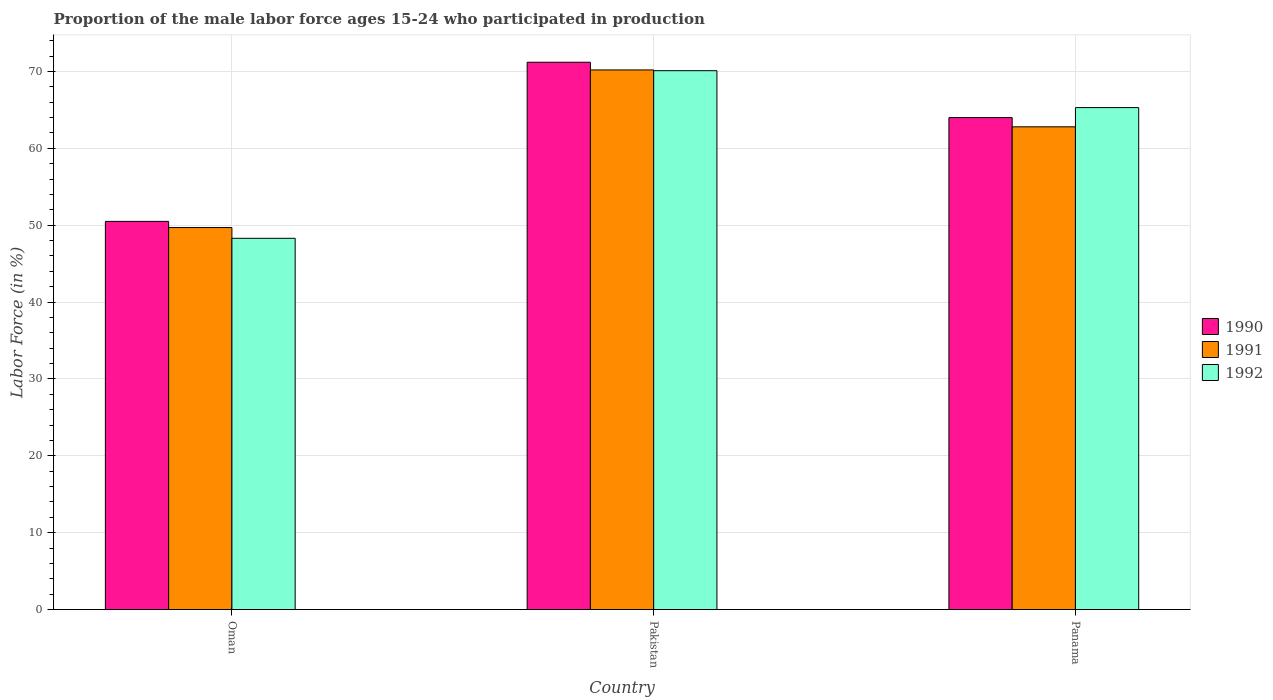How many different coloured bars are there?
Provide a short and direct response. 3. How many groups of bars are there?
Offer a terse response. 3. How many bars are there on the 3rd tick from the left?
Your response must be concise. 3. What is the label of the 3rd group of bars from the left?
Give a very brief answer. Panama. In how many cases, is the number of bars for a given country not equal to the number of legend labels?
Your answer should be very brief. 0. What is the proportion of the male labor force who participated in production in 1990 in Pakistan?
Your response must be concise. 71.2. Across all countries, what is the maximum proportion of the male labor force who participated in production in 1992?
Your response must be concise. 70.1. Across all countries, what is the minimum proportion of the male labor force who participated in production in 1991?
Make the answer very short. 49.7. In which country was the proportion of the male labor force who participated in production in 1992 maximum?
Your answer should be very brief. Pakistan. In which country was the proportion of the male labor force who participated in production in 1991 minimum?
Offer a terse response. Oman. What is the total proportion of the male labor force who participated in production in 1991 in the graph?
Make the answer very short. 182.7. What is the difference between the proportion of the male labor force who participated in production in 1990 in Oman and that in Panama?
Make the answer very short. -13.5. What is the difference between the proportion of the male labor force who participated in production in 1992 in Pakistan and the proportion of the male labor force who participated in production in 1990 in Panama?
Your answer should be compact. 6.1. What is the average proportion of the male labor force who participated in production in 1992 per country?
Your answer should be compact. 61.23. What is the difference between the proportion of the male labor force who participated in production of/in 1991 and proportion of the male labor force who participated in production of/in 1992 in Oman?
Provide a short and direct response. 1.4. What is the ratio of the proportion of the male labor force who participated in production in 1992 in Oman to that in Panama?
Your response must be concise. 0.74. What is the difference between the highest and the second highest proportion of the male labor force who participated in production in 1991?
Offer a terse response. 13.1. What is the difference between the highest and the lowest proportion of the male labor force who participated in production in 1991?
Your answer should be compact. 20.5. In how many countries, is the proportion of the male labor force who participated in production in 1990 greater than the average proportion of the male labor force who participated in production in 1990 taken over all countries?
Give a very brief answer. 2. What does the 3rd bar from the left in Oman represents?
Offer a terse response. 1992. Is it the case that in every country, the sum of the proportion of the male labor force who participated in production in 1992 and proportion of the male labor force who participated in production in 1991 is greater than the proportion of the male labor force who participated in production in 1990?
Keep it short and to the point. Yes. How many bars are there?
Give a very brief answer. 9. Are all the bars in the graph horizontal?
Your answer should be compact. No. Are the values on the major ticks of Y-axis written in scientific E-notation?
Provide a succinct answer. No. Does the graph contain grids?
Make the answer very short. Yes. Where does the legend appear in the graph?
Your response must be concise. Center right. How many legend labels are there?
Your response must be concise. 3. How are the legend labels stacked?
Offer a very short reply. Vertical. What is the title of the graph?
Your response must be concise. Proportion of the male labor force ages 15-24 who participated in production. What is the label or title of the X-axis?
Give a very brief answer. Country. What is the label or title of the Y-axis?
Offer a terse response. Labor Force (in %). What is the Labor Force (in %) of 1990 in Oman?
Make the answer very short. 50.5. What is the Labor Force (in %) in 1991 in Oman?
Offer a very short reply. 49.7. What is the Labor Force (in %) in 1992 in Oman?
Provide a succinct answer. 48.3. What is the Labor Force (in %) of 1990 in Pakistan?
Offer a very short reply. 71.2. What is the Labor Force (in %) in 1991 in Pakistan?
Ensure brevity in your answer.  70.2. What is the Labor Force (in %) of 1992 in Pakistan?
Your answer should be compact. 70.1. What is the Labor Force (in %) of 1991 in Panama?
Make the answer very short. 62.8. What is the Labor Force (in %) of 1992 in Panama?
Your answer should be very brief. 65.3. Across all countries, what is the maximum Labor Force (in %) in 1990?
Make the answer very short. 71.2. Across all countries, what is the maximum Labor Force (in %) in 1991?
Ensure brevity in your answer.  70.2. Across all countries, what is the maximum Labor Force (in %) of 1992?
Offer a very short reply. 70.1. Across all countries, what is the minimum Labor Force (in %) in 1990?
Offer a terse response. 50.5. Across all countries, what is the minimum Labor Force (in %) in 1991?
Provide a succinct answer. 49.7. Across all countries, what is the minimum Labor Force (in %) of 1992?
Make the answer very short. 48.3. What is the total Labor Force (in %) of 1990 in the graph?
Ensure brevity in your answer.  185.7. What is the total Labor Force (in %) in 1991 in the graph?
Offer a very short reply. 182.7. What is the total Labor Force (in %) of 1992 in the graph?
Your response must be concise. 183.7. What is the difference between the Labor Force (in %) in 1990 in Oman and that in Pakistan?
Your response must be concise. -20.7. What is the difference between the Labor Force (in %) in 1991 in Oman and that in Pakistan?
Make the answer very short. -20.5. What is the difference between the Labor Force (in %) of 1992 in Oman and that in Pakistan?
Offer a very short reply. -21.8. What is the difference between the Labor Force (in %) of 1992 in Oman and that in Panama?
Give a very brief answer. -17. What is the difference between the Labor Force (in %) in 1991 in Pakistan and that in Panama?
Offer a very short reply. 7.4. What is the difference between the Labor Force (in %) in 1992 in Pakistan and that in Panama?
Offer a terse response. 4.8. What is the difference between the Labor Force (in %) of 1990 in Oman and the Labor Force (in %) of 1991 in Pakistan?
Offer a terse response. -19.7. What is the difference between the Labor Force (in %) of 1990 in Oman and the Labor Force (in %) of 1992 in Pakistan?
Your answer should be compact. -19.6. What is the difference between the Labor Force (in %) in 1991 in Oman and the Labor Force (in %) in 1992 in Pakistan?
Provide a succinct answer. -20.4. What is the difference between the Labor Force (in %) of 1990 in Oman and the Labor Force (in %) of 1992 in Panama?
Your answer should be very brief. -14.8. What is the difference between the Labor Force (in %) of 1991 in Oman and the Labor Force (in %) of 1992 in Panama?
Provide a short and direct response. -15.6. What is the difference between the Labor Force (in %) of 1990 in Pakistan and the Labor Force (in %) of 1991 in Panama?
Offer a very short reply. 8.4. What is the difference between the Labor Force (in %) in 1990 in Pakistan and the Labor Force (in %) in 1992 in Panama?
Make the answer very short. 5.9. What is the average Labor Force (in %) of 1990 per country?
Your answer should be very brief. 61.9. What is the average Labor Force (in %) in 1991 per country?
Your answer should be very brief. 60.9. What is the average Labor Force (in %) of 1992 per country?
Your answer should be very brief. 61.23. What is the difference between the Labor Force (in %) of 1991 and Labor Force (in %) of 1992 in Oman?
Your answer should be very brief. 1.4. What is the difference between the Labor Force (in %) of 1990 and Labor Force (in %) of 1992 in Pakistan?
Your response must be concise. 1.1. What is the difference between the Labor Force (in %) in 1990 and Labor Force (in %) in 1991 in Panama?
Make the answer very short. 1.2. What is the difference between the Labor Force (in %) of 1990 and Labor Force (in %) of 1992 in Panama?
Give a very brief answer. -1.3. What is the difference between the Labor Force (in %) of 1991 and Labor Force (in %) of 1992 in Panama?
Provide a succinct answer. -2.5. What is the ratio of the Labor Force (in %) of 1990 in Oman to that in Pakistan?
Your response must be concise. 0.71. What is the ratio of the Labor Force (in %) of 1991 in Oman to that in Pakistan?
Offer a very short reply. 0.71. What is the ratio of the Labor Force (in %) in 1992 in Oman to that in Pakistan?
Make the answer very short. 0.69. What is the ratio of the Labor Force (in %) of 1990 in Oman to that in Panama?
Offer a terse response. 0.79. What is the ratio of the Labor Force (in %) in 1991 in Oman to that in Panama?
Offer a terse response. 0.79. What is the ratio of the Labor Force (in %) in 1992 in Oman to that in Panama?
Ensure brevity in your answer.  0.74. What is the ratio of the Labor Force (in %) of 1990 in Pakistan to that in Panama?
Give a very brief answer. 1.11. What is the ratio of the Labor Force (in %) in 1991 in Pakistan to that in Panama?
Provide a short and direct response. 1.12. What is the ratio of the Labor Force (in %) of 1992 in Pakistan to that in Panama?
Make the answer very short. 1.07. What is the difference between the highest and the second highest Labor Force (in %) in 1990?
Your answer should be compact. 7.2. What is the difference between the highest and the second highest Labor Force (in %) of 1991?
Your response must be concise. 7.4. What is the difference between the highest and the second highest Labor Force (in %) of 1992?
Ensure brevity in your answer.  4.8. What is the difference between the highest and the lowest Labor Force (in %) of 1990?
Give a very brief answer. 20.7. What is the difference between the highest and the lowest Labor Force (in %) of 1992?
Offer a very short reply. 21.8. 